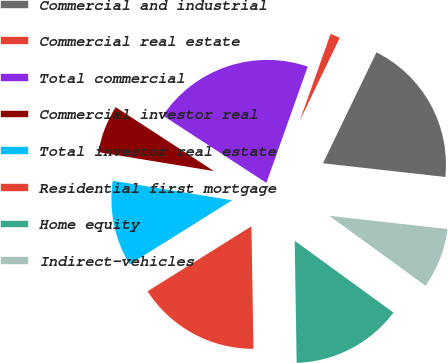Convert chart. <chart><loc_0><loc_0><loc_500><loc_500><pie_chart><fcel>Commercial and industrial<fcel>Commercial real estate<fcel>Total commercial<fcel>Commercial investor real<fcel>Total investor real estate<fcel>Residential first mortgage<fcel>Home equity<fcel>Indirect-vehicles<nl><fcel>19.62%<fcel>1.72%<fcel>21.25%<fcel>6.6%<fcel>11.48%<fcel>16.36%<fcel>14.74%<fcel>8.23%<nl></chart> 